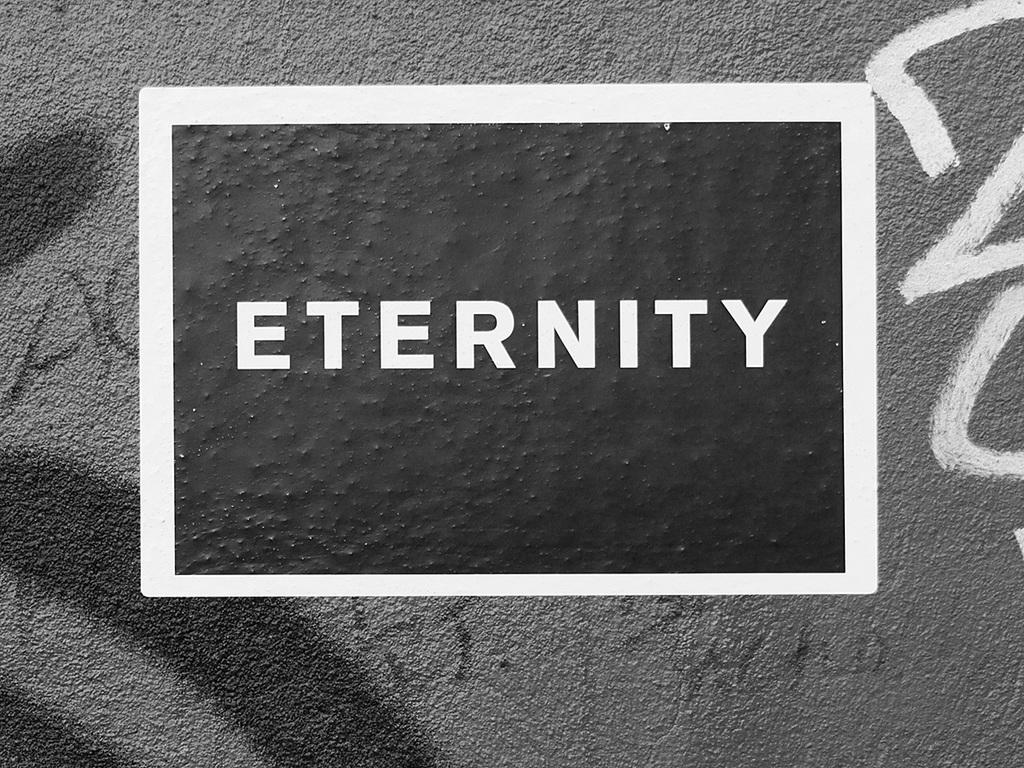Provide a one-sentence caption for the provided image. a sign reading Eternity on a wall of grafitti. 